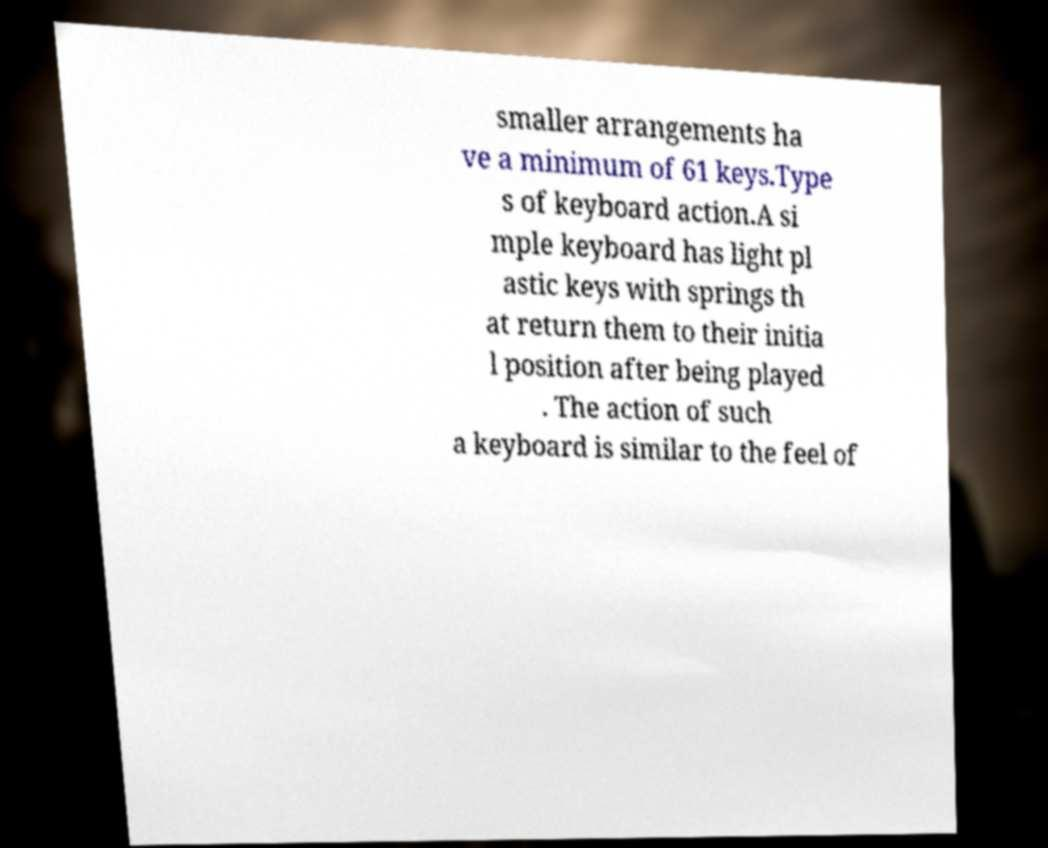Please identify and transcribe the text found in this image. smaller arrangements ha ve a minimum of 61 keys.Type s of keyboard action.A si mple keyboard has light pl astic keys with springs th at return them to their initia l position after being played . The action of such a keyboard is similar to the feel of 